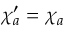Convert formula to latex. <formula><loc_0><loc_0><loc_500><loc_500>\chi _ { a } ^ { \prime } = \chi _ { a }</formula> 